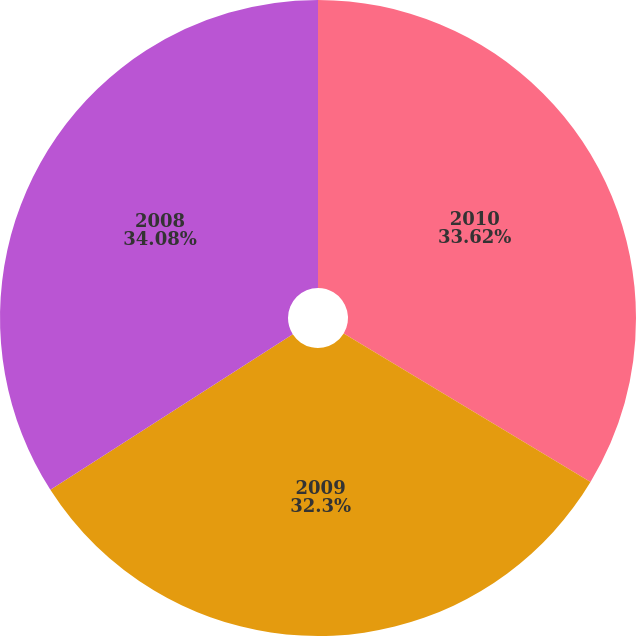<chart> <loc_0><loc_0><loc_500><loc_500><pie_chart><fcel>2010<fcel>2009<fcel>2008<nl><fcel>33.62%<fcel>32.3%<fcel>34.08%<nl></chart> 